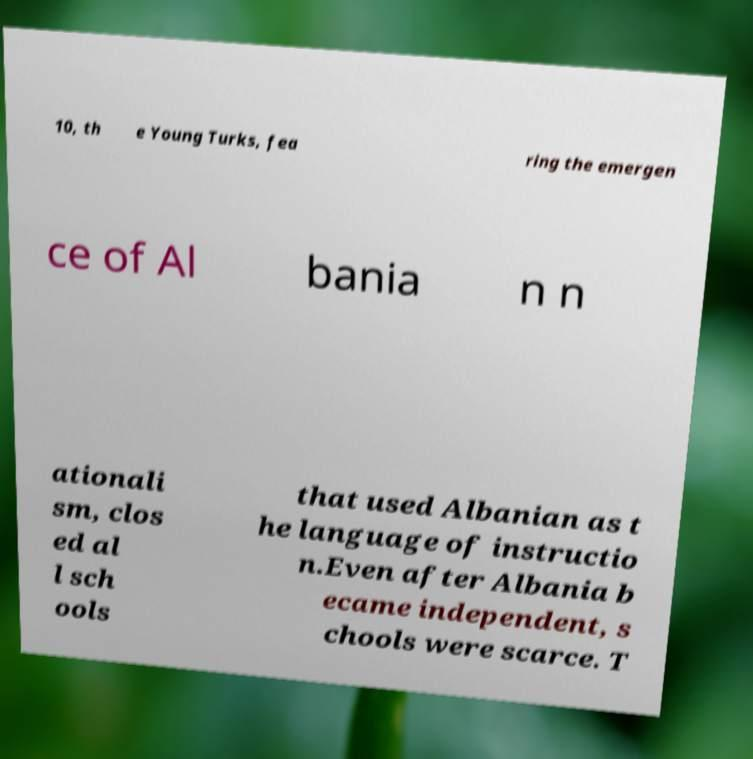Could you assist in decoding the text presented in this image and type it out clearly? 10, th e Young Turks, fea ring the emergen ce of Al bania n n ationali sm, clos ed al l sch ools that used Albanian as t he language of instructio n.Even after Albania b ecame independent, s chools were scarce. T 